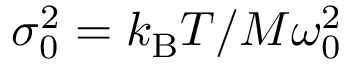<formula> <loc_0><loc_0><loc_500><loc_500>\sigma _ { 0 } ^ { 2 } = k _ { B } T / M \omega _ { 0 } ^ { 2 }</formula> 